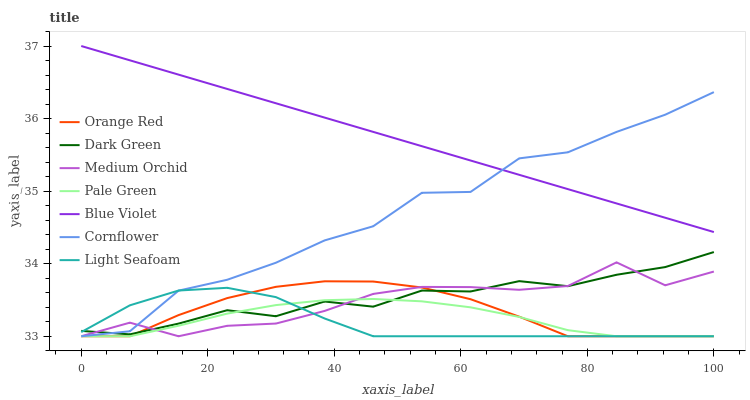Does Light Seafoam have the minimum area under the curve?
Answer yes or no. Yes. Does Blue Violet have the maximum area under the curve?
Answer yes or no. Yes. Does Medium Orchid have the minimum area under the curve?
Answer yes or no. No. Does Medium Orchid have the maximum area under the curve?
Answer yes or no. No. Is Blue Violet the smoothest?
Answer yes or no. Yes. Is Cornflower the roughest?
Answer yes or no. Yes. Is Medium Orchid the smoothest?
Answer yes or no. No. Is Medium Orchid the roughest?
Answer yes or no. No. Does Blue Violet have the lowest value?
Answer yes or no. No. Does Medium Orchid have the highest value?
Answer yes or no. No. Is Light Seafoam less than Blue Violet?
Answer yes or no. Yes. Is Blue Violet greater than Light Seafoam?
Answer yes or no. Yes. Does Light Seafoam intersect Blue Violet?
Answer yes or no. No. 